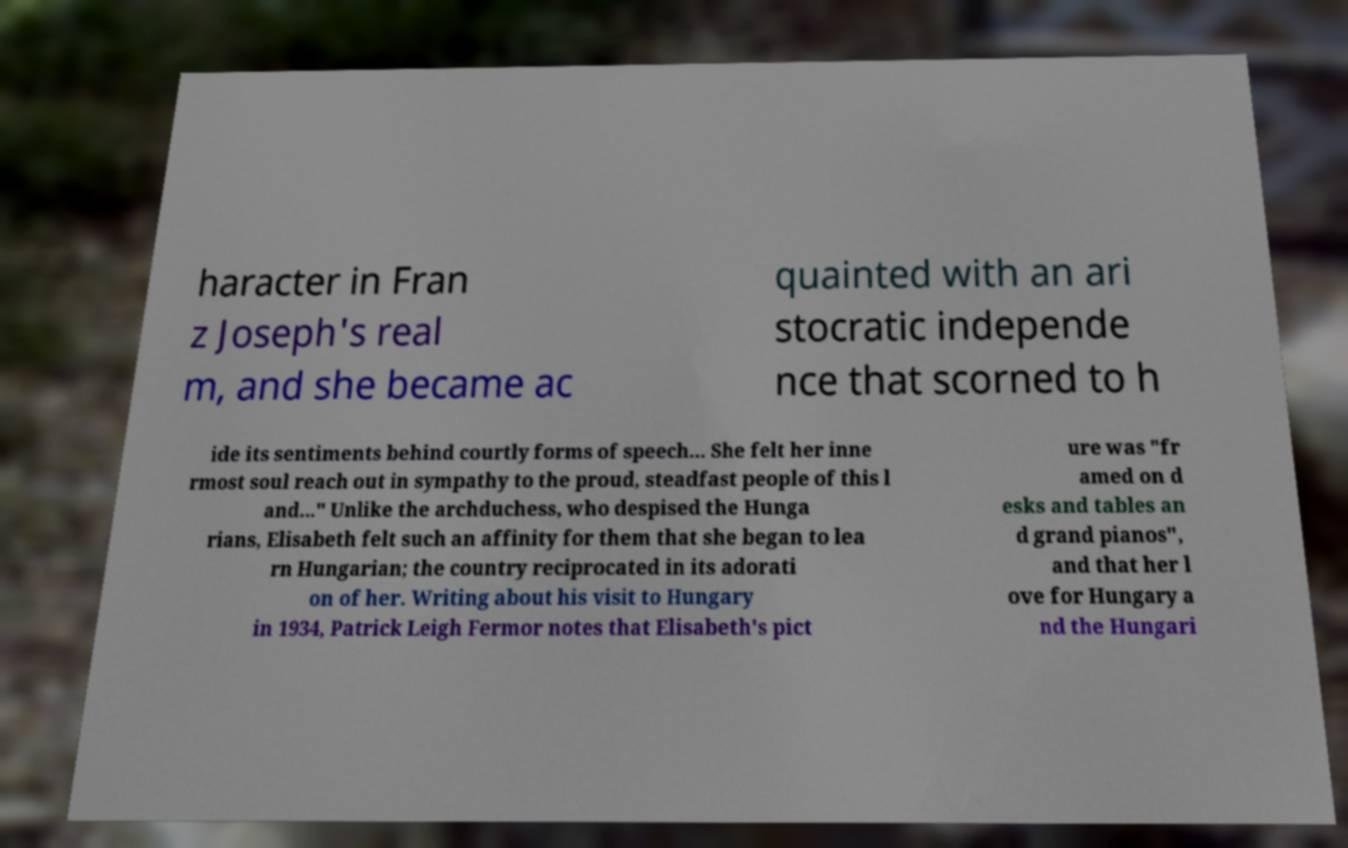Please read and relay the text visible in this image. What does it say? haracter in Fran z Joseph's real m, and she became ac quainted with an ari stocratic independe nce that scorned to h ide its sentiments behind courtly forms of speech... She felt her inne rmost soul reach out in sympathy to the proud, steadfast people of this l and..." Unlike the archduchess, who despised the Hunga rians, Elisabeth felt such an affinity for them that she began to lea rn Hungarian; the country reciprocated in its adorati on of her. Writing about his visit to Hungary in 1934, Patrick Leigh Fermor notes that Elisabeth's pict ure was "fr amed on d esks and tables an d grand pianos", and that her l ove for Hungary a nd the Hungari 